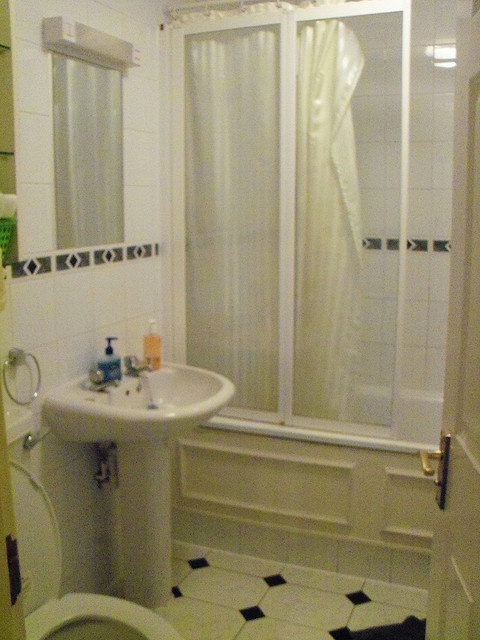Describe the objects in this image and their specific colors. I can see toilet in olive tones, sink in olive, tan, and gray tones, bottle in olive, gray, navy, black, and blue tones, and bottle in olive and tan tones in this image. 